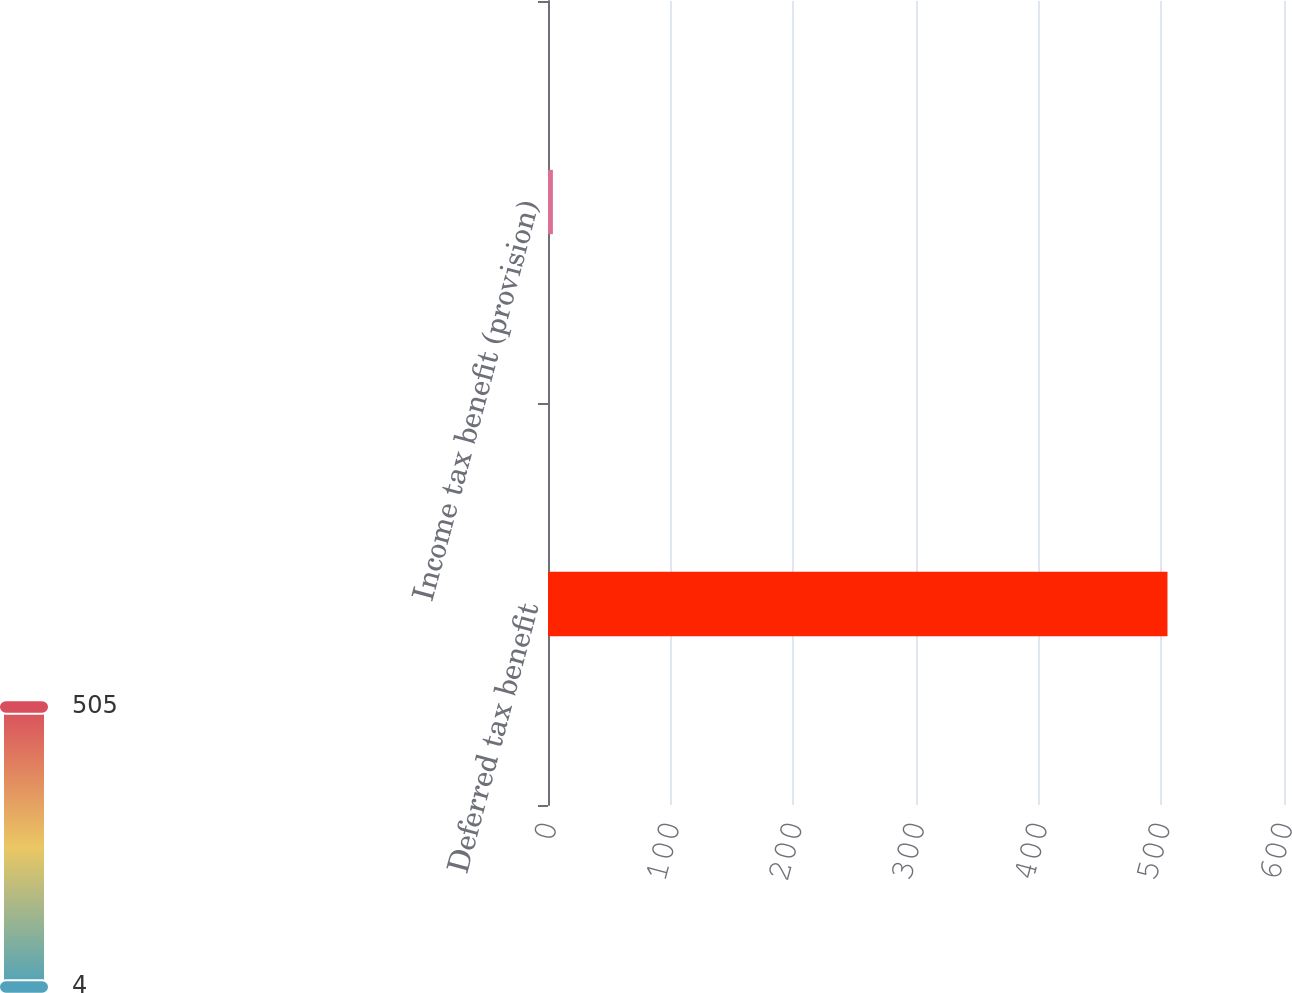Convert chart. <chart><loc_0><loc_0><loc_500><loc_500><bar_chart><fcel>Deferred tax benefit<fcel>Income tax benefit (provision)<nl><fcel>505<fcel>4<nl></chart> 